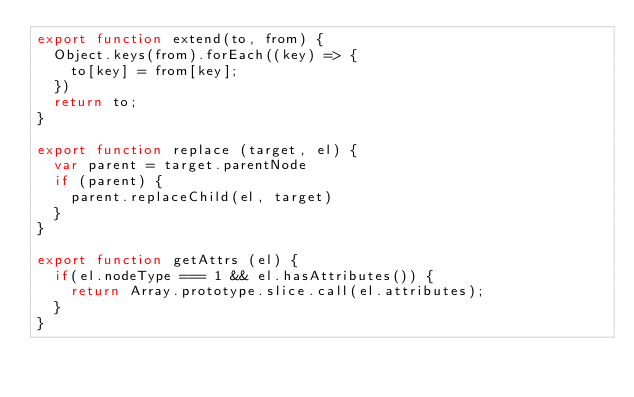<code> <loc_0><loc_0><loc_500><loc_500><_JavaScript_>export function extend(to, from) {
	Object.keys(from).forEach((key) => {
		to[key] = from[key];
	})
	return to;
}

export function replace (target, el) {
  var parent = target.parentNode
  if (parent) {
    parent.replaceChild(el, target)
  }
}

export function getAttrs (el) {
	if(el.nodeType === 1 && el.hasAttributes()) {
		return Array.prototype.slice.call(el.attributes);
	}
}</code> 